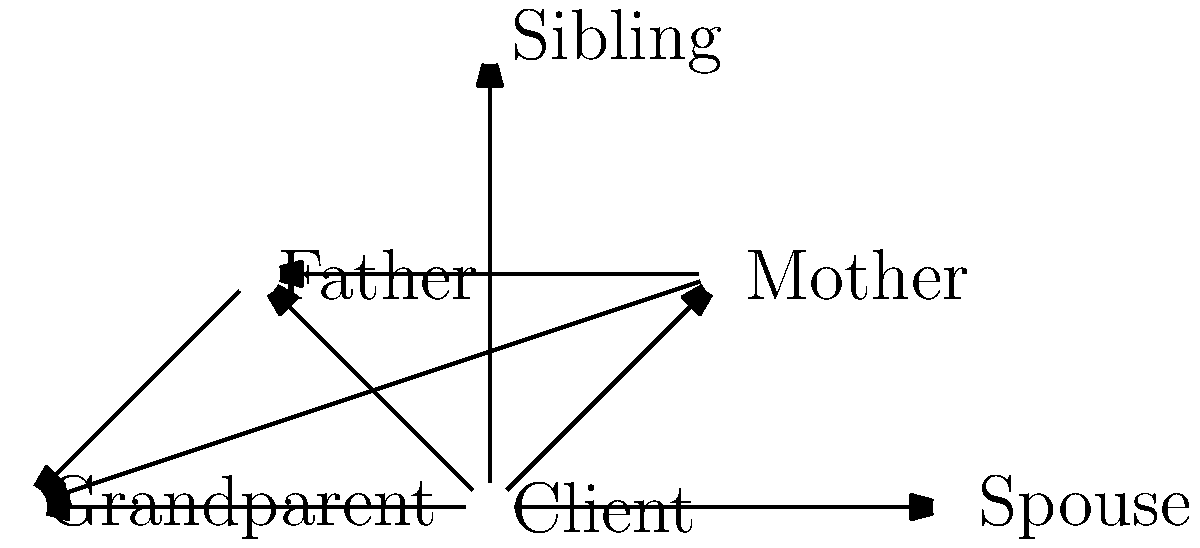In the family relationship network shown above, which family member has the highest degree centrality, and how might this impact the client's mental health in a therapeutic context? To answer this question, we need to follow these steps:

1. Understand degree centrality:
   Degree centrality is the number of direct connections a node has in a network.

2. Count connections for each family member:
   Client: 5 connections
   Mother: 3 connections
   Father: 3 connections
   Sibling: 1 connection
   Grandparent: 3 connections
   Spouse: 1 connection

3. Identify the highest degree centrality:
   The Client has the highest degree centrality with 5 connections.

4. Analyze the impact on mental health:
   a) The client being central suggests they are heavily influenced by multiple family relationships.
   b) This high connectivity can lead to increased emotional support but also potential stress from managing multiple relationships.
   c) The client may feel responsible for maintaining family harmony, which could be both empowering and burdensome.
   d) Multiple connections provide diverse perspectives for the client, potentially aiding in problem-solving but also potentially leading to conflicting advice.
   e) The therapist should explore how the client navigates these relationships and their impact on mental well-being.

5. Therapeutic context:
   The therapist should focus on helping the client balance these relationships, set healthy boundaries, and utilize the support network effectively for positive mental health outcomes.
Answer: The Client has the highest degree centrality (5 connections), potentially leading to increased support but also stress from managing multiple influential relationships. 